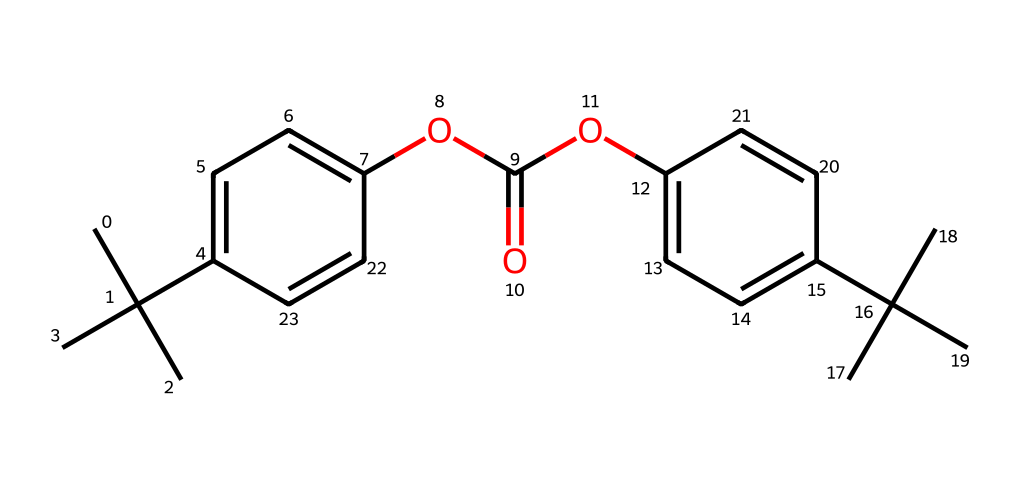What is the total number of carbon atoms in this molecule? To find the total number of carbon atoms, count each carbon (C) present in the SMILES representation. The molecular structure contains several isopropyl groups and aromatic rings, contributing to a total of 22 carbon atoms.
Answer: 22 How many oxygen atoms are present in this structure? Examine the SMILES string for the presence of oxygen (O). The molecule shows two distinct ester linkages, indicating two oxygen atoms present in the structure.
Answer: 3 What kind of functional group is indicated by "OC(=O)" in the chemical? The segment "OC(=O)" indicates the presence of an ester functional group. This is recognized by the carbonyl (C=O) connected to the oxygen (O).
Answer: ester Does this molecule possess aromatic characteristics? The structure features two benzene rings, evident from the alternating double bonds. The presence of these cyclic, planar arrangements confirms its aromatic characteristics.
Answer: yes How many distinct rings can be identified in the structure? By analyzing the molecular structure, you can identify two distinct aromatic rings that are part of the whole molecule. Each benzene unit represents a separate ring.
Answer: 2 What is the molecular weight of this compound? To determine the molecular weight, calculate the contributions of carbon, hydrogen, and oxygen present in the molecule. The final summed weight yields approximately 318.5 g/mol.
Answer: approximately 318.5 g/mol 